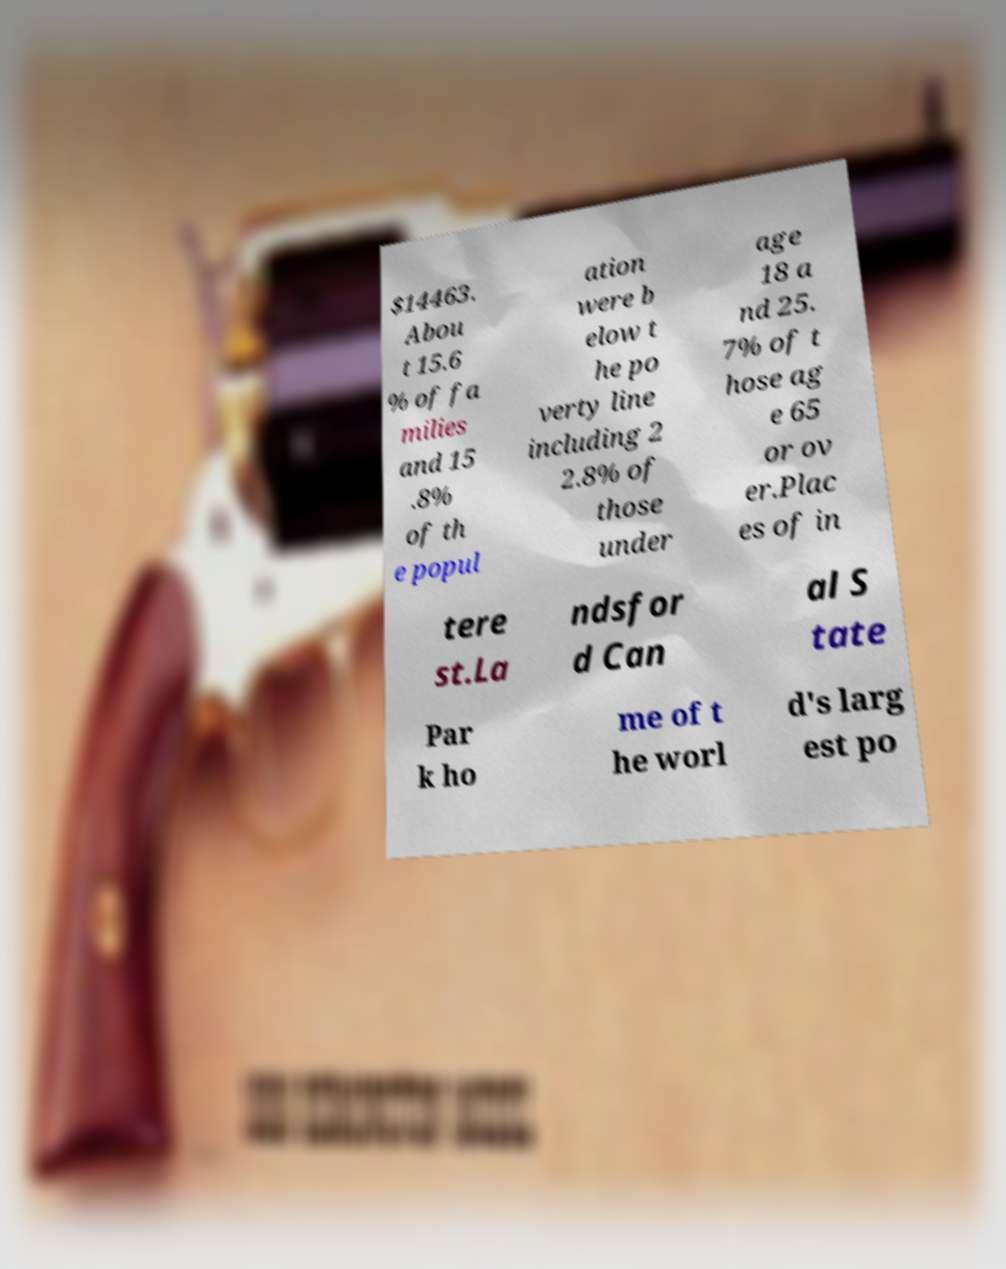What messages or text are displayed in this image? I need them in a readable, typed format. $14463. Abou t 15.6 % of fa milies and 15 .8% of th e popul ation were b elow t he po verty line including 2 2.8% of those under age 18 a nd 25. 7% of t hose ag e 65 or ov er.Plac es of in tere st.La ndsfor d Can al S tate Par k ho me of t he worl d's larg est po 